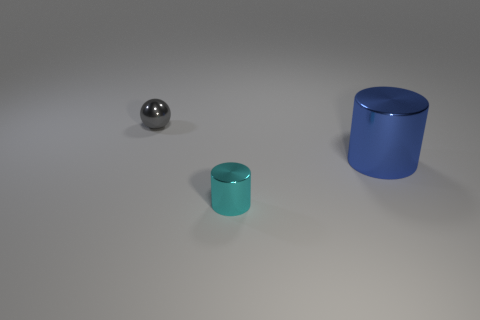Subtract all purple cylinders. Subtract all cyan balls. How many cylinders are left? 2 Subtract all cyan cylinders. How many yellow spheres are left? 0 Add 1 cyans. How many big things exist? 0 Subtract all big gray shiny balls. Subtract all metal objects. How many objects are left? 0 Add 3 metallic spheres. How many metallic spheres are left? 4 Add 1 tiny gray balls. How many tiny gray balls exist? 2 Add 1 big blue things. How many objects exist? 4 Subtract all blue cylinders. How many cylinders are left? 1 Subtract 0 yellow cylinders. How many objects are left? 3 Subtract all cylinders. How many objects are left? 1 